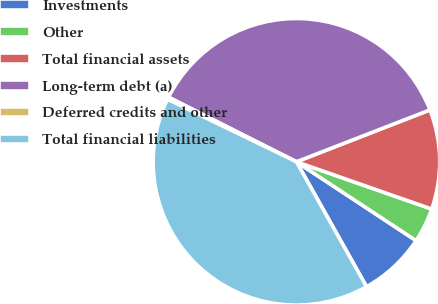Convert chart. <chart><loc_0><loc_0><loc_500><loc_500><pie_chart><fcel>Investments<fcel>Other<fcel>Total financial assets<fcel>Long-term debt (a)<fcel>Deferred credits and other<fcel>Total financial liabilities<nl><fcel>7.59%<fcel>3.92%<fcel>11.25%<fcel>36.66%<fcel>0.26%<fcel>40.32%<nl></chart> 